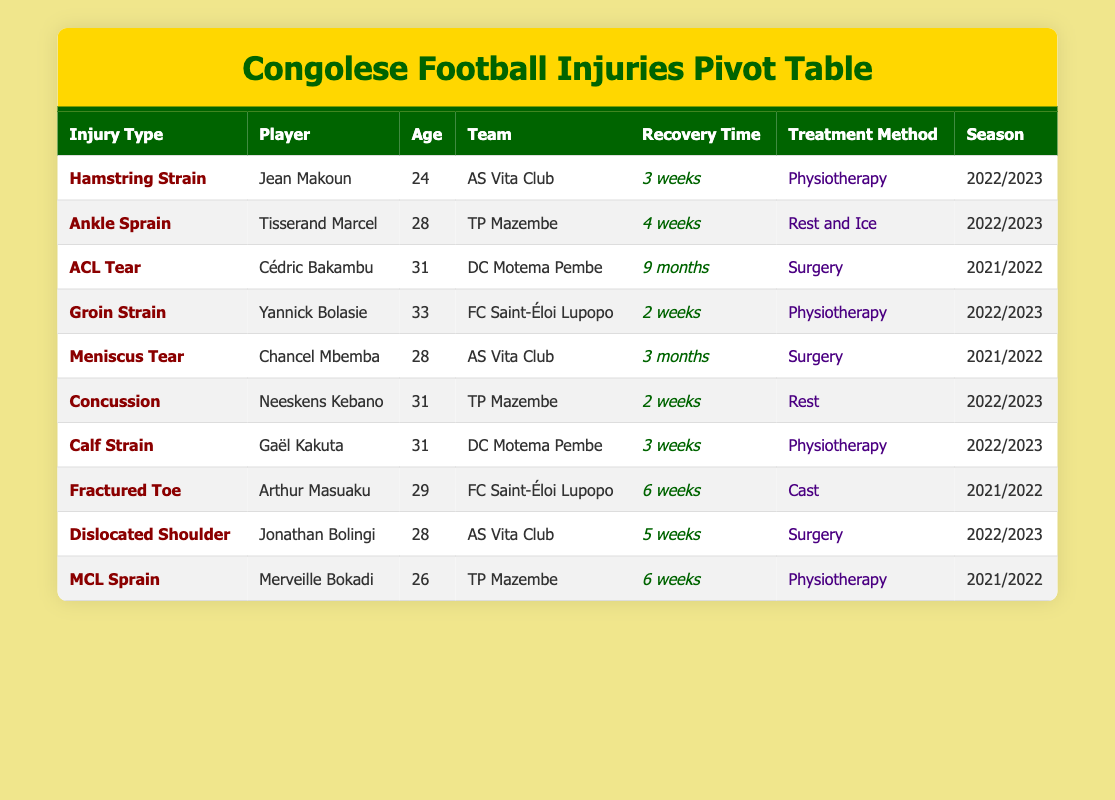What is the recovery time for Jean Makoun? The table states that Jean Makoun has a recovery time of 3 weeks, as indicated in the "Recovery Time" column under the row for him.
Answer: 3 weeks Which player has the longest recovery time? Cédric Bakambu has the longest recovery time of 9 months, which is the maximum value listed in the Recovery Time column throughout all entries in the table.
Answer: Cédric Bakambu How many players had a recovery time of 2 weeks? By reviewing the table, both Yannick Bolasie and Neeskens Kebano have a recovery time of 2 weeks. Therefore, counting these entries gives us a total of 2 players.
Answer: 2 players Is it true that all injuries listed required surgery? Not all injuries listed required surgery; for instance, Jean Makoun's injury involved physiotherapy as a treatment method. This indicates that the statement is not true.
Answer: No What is the average recovery time (in weeks) for players treated with physiotherapy? The players treated with physiotherapy are Jean Makoun (3 weeks), Yannick Bolasie (2 weeks), Gaël Kakuta (3 weeks), and Merveille Bokadi (6 weeks). Adding these together gives 3 + 2 + 3 + 6 = 14 weeks. There are 4 players, so the average is 14 / 4 = 3.5 weeks.
Answer: 3.5 weeks Which team had players with the most diverse injury types listed? Assessing the table, the team AS Vita Club featured various injury types, including Hamstring Strain, Meniscus Tear, and Dislocated Shoulder for its players, indicating a diverse range.
Answer: AS Vita Club What percentage of the players listed had injuries that healed within 4 weeks or less? Among the total of 10 players, 5 had recovery times of 4 weeks or less: Jean Makoun (3 weeks), Yannick Bolasie (2 weeks), Neeskens Kebano (2 weeks), Gaël Kakuta (3 weeks), and Tisserand Marcel (4 weeks). Calculating gives us 5 out of 10, which is 50%.
Answer: 50% How many players are using surgery as a treatment method? By examining the table, 3 players—Cédric Bakambu, Chancel Mbemba, and Jonathan Bolingi—are listed with surgery as their treatment method for their injuries. Counting these entries yields a total of 3 players.
Answer: 3 players 